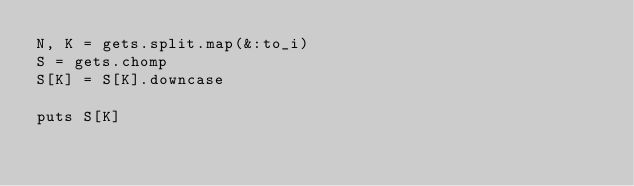Convert code to text. <code><loc_0><loc_0><loc_500><loc_500><_Ruby_>N, K = gets.split.map(&:to_i)
S = gets.chomp
S[K] = S[K].downcase

puts S[K]
</code> 